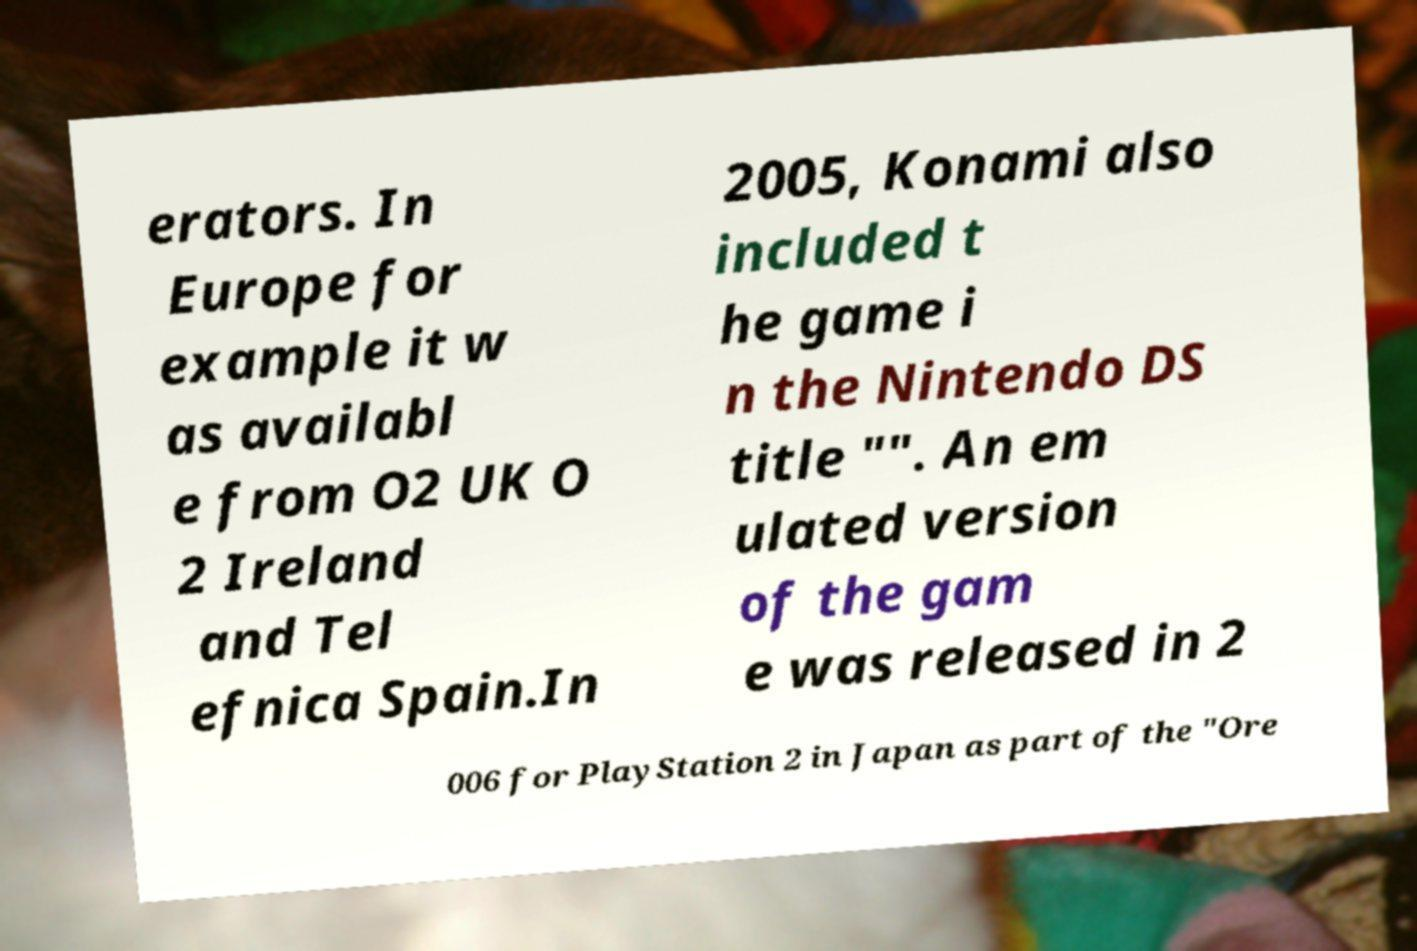I need the written content from this picture converted into text. Can you do that? erators. In Europe for example it w as availabl e from O2 UK O 2 Ireland and Tel efnica Spain.In 2005, Konami also included t he game i n the Nintendo DS title "". An em ulated version of the gam e was released in 2 006 for PlayStation 2 in Japan as part of the "Ore 